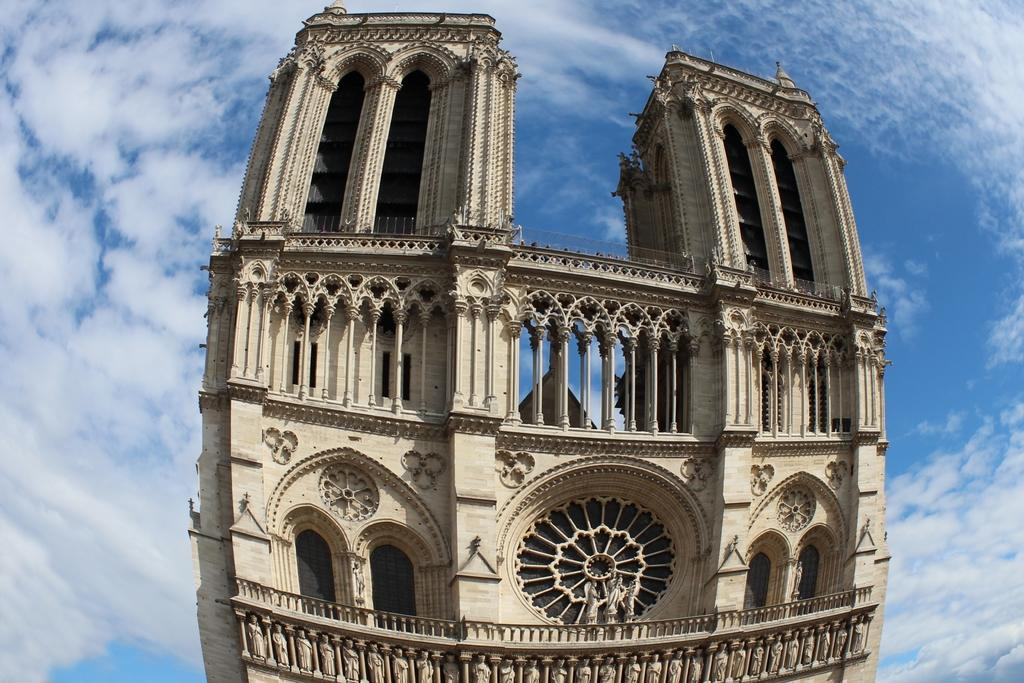What is the main structure in the image? There is a building in the image. What decorative elements can be seen on the building? There are sculptures on the building. What can be seen in the background of the image? The sky is visible in the background of the image. What is the weather like in the image? The presence of clouds in the sky suggests that it might be partly cloudy. What type of tax is being discussed at the party in the image? There is no party or tax present in the image; it features a building with sculptures and a sky with clouds. How quiet is the environment in the image? The image does not provide any information about the noise level or the presence of people, so it is not possible to determine the quietness of the environment. 